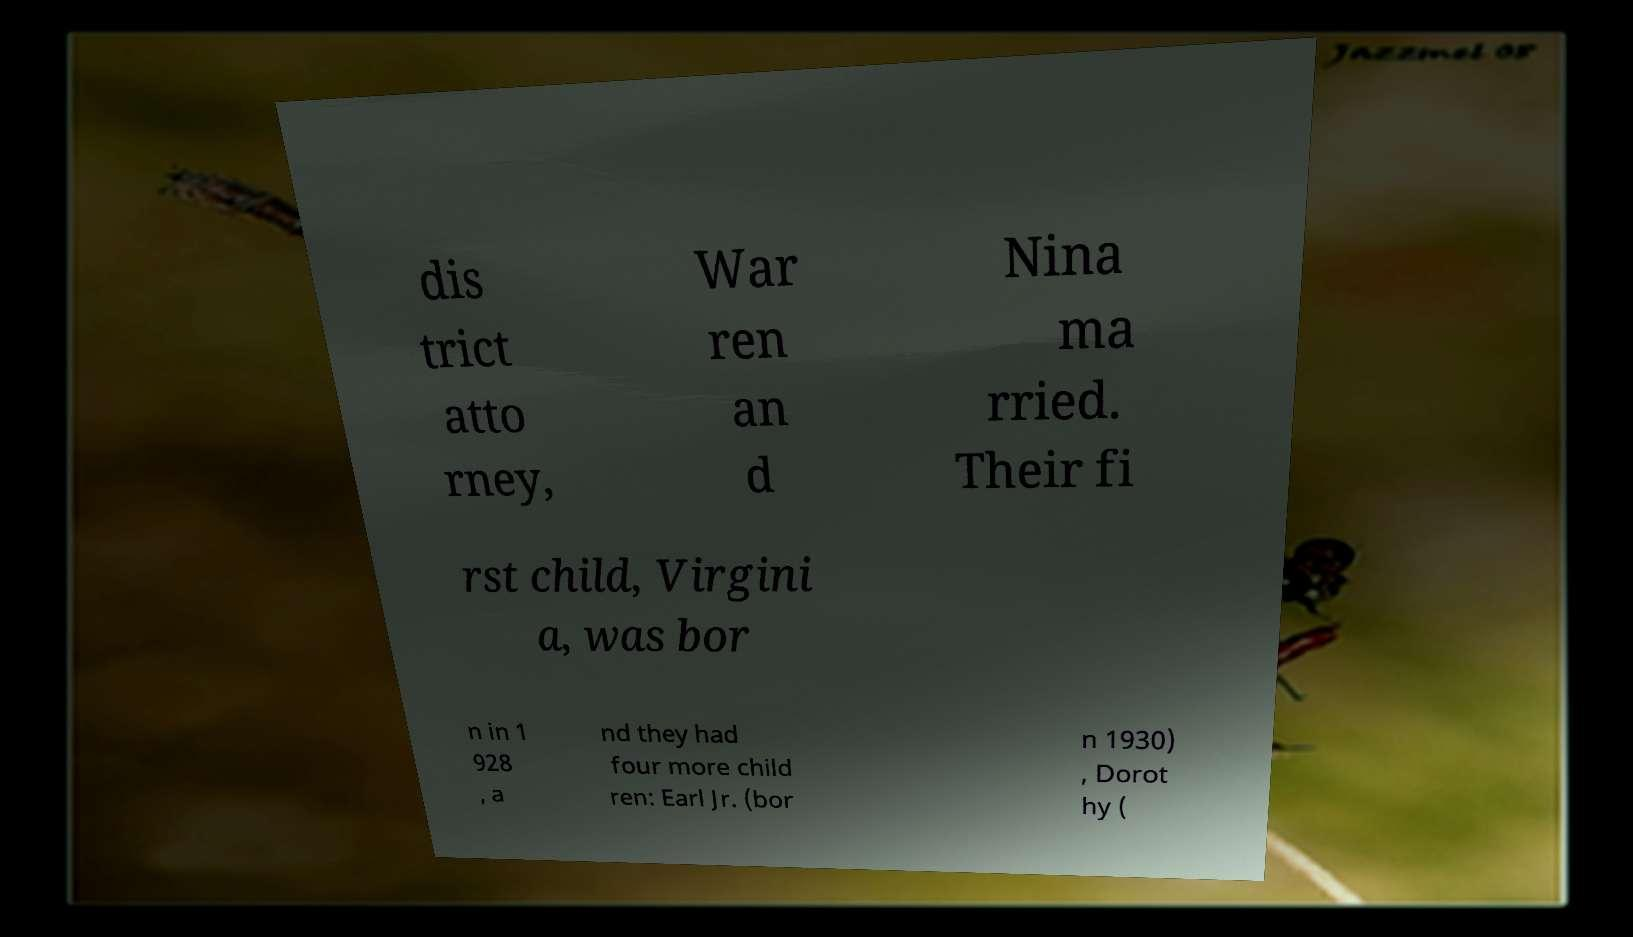Can you accurately transcribe the text from the provided image for me? dis trict atto rney, War ren an d Nina ma rried. Their fi rst child, Virgini a, was bor n in 1 928 , a nd they had four more child ren: Earl Jr. (bor n 1930) , Dorot hy ( 